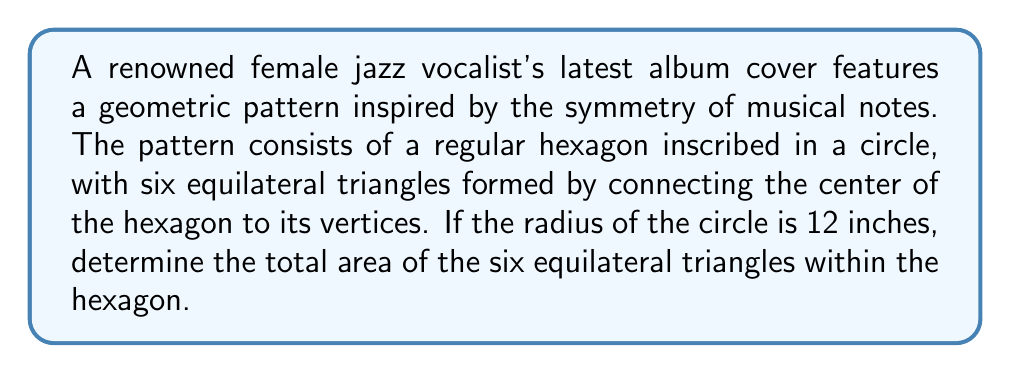Can you solve this math problem? Let's approach this step-by-step:

1) First, we need to find the side length of the hexagon. In a regular hexagon inscribed in a circle, the side length is equal to the radius. So, the side length $s = 12$ inches.

2) Now, we need to find the area of one equilateral triangle. The formula for the area of an equilateral triangle is:

   $$A = \frac{\sqrt{3}}{4}a^2$$

   where $a$ is the side length of the triangle.

3) To find the side length of the equilateral triangle, we need to calculate the apothem of the hexagon. The apothem is the distance from the center to the midpoint of any side. It can be calculated as:

   $$\text{apothem} = r \cdot \cos(30°) = 12 \cdot \frac{\sqrt{3}}{2} = 6\sqrt{3}$$

4) The side length of each equilateral triangle is equal to the radius of the circle, which is 12 inches.

5) Now we can calculate the area of one equilateral triangle:

   $$A = \frac{\sqrt{3}}{4}(12)^2 = 36\sqrt{3}$$

6) Since there are six identical triangles, we multiply this result by 6:

   $$\text{Total Area} = 6 \cdot 36\sqrt{3} = 216\sqrt{3}$$

Therefore, the total area of the six equilateral triangles is $216\sqrt{3}$ square inches.
Answer: $216\sqrt{3}$ square inches 